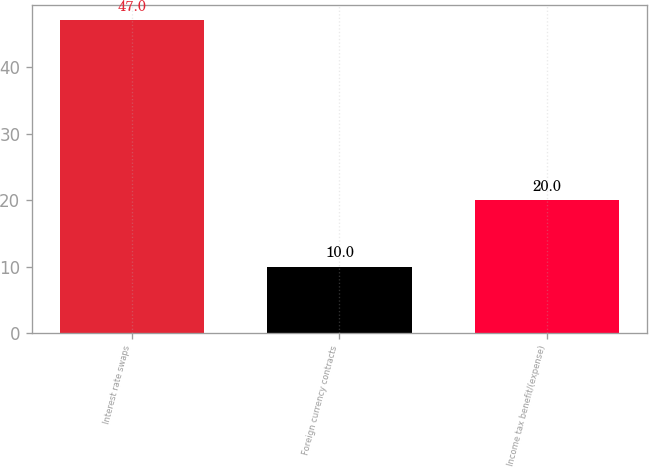Convert chart. <chart><loc_0><loc_0><loc_500><loc_500><bar_chart><fcel>Interest rate swaps<fcel>Foreign currency contracts<fcel>Income tax benefit/(expense)<nl><fcel>47<fcel>10<fcel>20<nl></chart> 